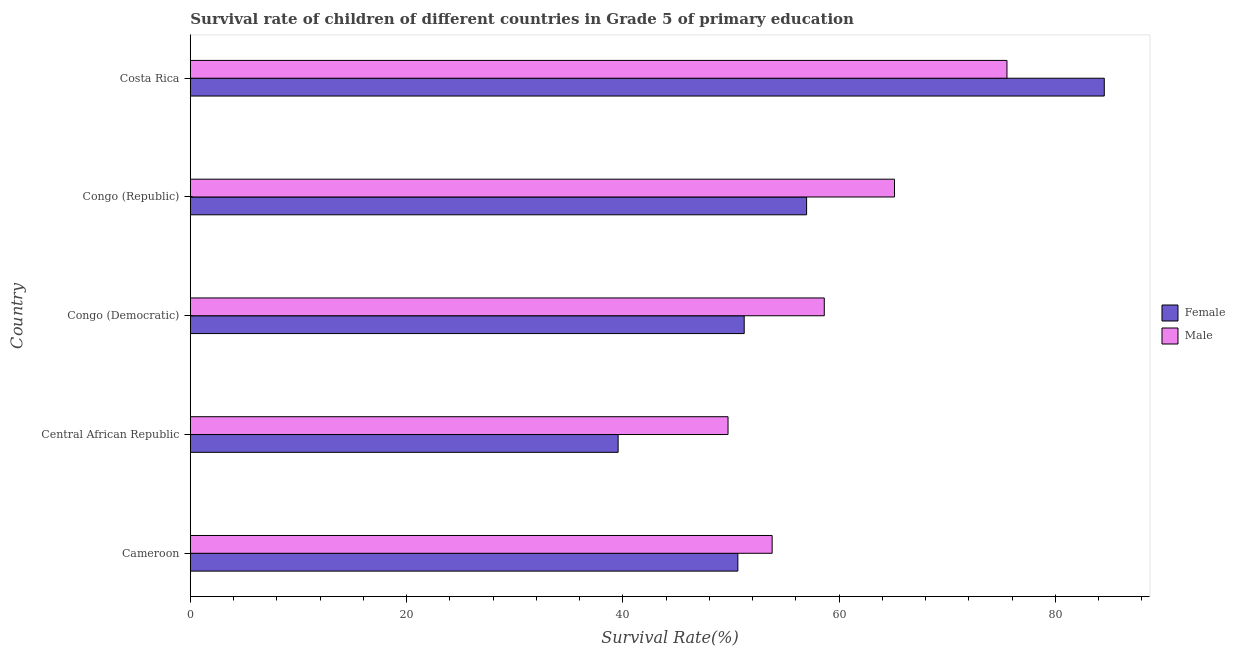How many groups of bars are there?
Ensure brevity in your answer.  5. How many bars are there on the 4th tick from the bottom?
Your answer should be very brief. 2. What is the label of the 5th group of bars from the top?
Your response must be concise. Cameroon. What is the survival rate of male students in primary education in Congo (Republic)?
Your answer should be very brief. 65.13. Across all countries, what is the maximum survival rate of male students in primary education?
Give a very brief answer. 75.53. Across all countries, what is the minimum survival rate of male students in primary education?
Provide a succinct answer. 49.73. In which country was the survival rate of male students in primary education maximum?
Offer a terse response. Costa Rica. In which country was the survival rate of female students in primary education minimum?
Ensure brevity in your answer.  Central African Republic. What is the total survival rate of female students in primary education in the graph?
Your answer should be compact. 282.97. What is the difference between the survival rate of female students in primary education in Cameroon and that in Costa Rica?
Your answer should be very brief. -33.89. What is the difference between the survival rate of male students in primary education in Costa Rica and the survival rate of female students in primary education in Cameroon?
Your response must be concise. 24.89. What is the average survival rate of female students in primary education per country?
Ensure brevity in your answer.  56.59. What is the difference between the survival rate of male students in primary education and survival rate of female students in primary education in Central African Republic?
Provide a short and direct response. 10.16. What is the ratio of the survival rate of female students in primary education in Cameroon to that in Congo (Republic)?
Offer a terse response. 0.89. Is the survival rate of female students in primary education in Congo (Democratic) less than that in Congo (Republic)?
Make the answer very short. Yes. Is the difference between the survival rate of male students in primary education in Cameroon and Costa Rica greater than the difference between the survival rate of female students in primary education in Cameroon and Costa Rica?
Offer a very short reply. Yes. What is the difference between the highest and the second highest survival rate of female students in primary education?
Your answer should be very brief. 27.53. What is the difference between the highest and the lowest survival rate of female students in primary education?
Provide a short and direct response. 44.96. In how many countries, is the survival rate of female students in primary education greater than the average survival rate of female students in primary education taken over all countries?
Offer a very short reply. 2. What does the 2nd bar from the bottom in Cameroon represents?
Your answer should be compact. Male. Are the values on the major ticks of X-axis written in scientific E-notation?
Your response must be concise. No. Does the graph contain any zero values?
Your answer should be compact. No. How many legend labels are there?
Ensure brevity in your answer.  2. How are the legend labels stacked?
Offer a very short reply. Vertical. What is the title of the graph?
Offer a very short reply. Survival rate of children of different countries in Grade 5 of primary education. Does "Nitrous oxide emissions" appear as one of the legend labels in the graph?
Your answer should be compact. No. What is the label or title of the X-axis?
Provide a succinct answer. Survival Rate(%). What is the label or title of the Y-axis?
Provide a succinct answer. Country. What is the Survival Rate(%) in Female in Cameroon?
Provide a short and direct response. 50.64. What is the Survival Rate(%) in Male in Cameroon?
Your answer should be compact. 53.81. What is the Survival Rate(%) in Female in Central African Republic?
Provide a succinct answer. 39.57. What is the Survival Rate(%) in Male in Central African Republic?
Your response must be concise. 49.73. What is the Survival Rate(%) in Female in Congo (Democratic)?
Your response must be concise. 51.23. What is the Survival Rate(%) of Male in Congo (Democratic)?
Your answer should be very brief. 58.64. What is the Survival Rate(%) in Female in Congo (Republic)?
Your response must be concise. 57. What is the Survival Rate(%) of Male in Congo (Republic)?
Your answer should be compact. 65.13. What is the Survival Rate(%) in Female in Costa Rica?
Provide a short and direct response. 84.53. What is the Survival Rate(%) of Male in Costa Rica?
Keep it short and to the point. 75.53. Across all countries, what is the maximum Survival Rate(%) of Female?
Provide a short and direct response. 84.53. Across all countries, what is the maximum Survival Rate(%) in Male?
Ensure brevity in your answer.  75.53. Across all countries, what is the minimum Survival Rate(%) of Female?
Your answer should be compact. 39.57. Across all countries, what is the minimum Survival Rate(%) of Male?
Ensure brevity in your answer.  49.73. What is the total Survival Rate(%) of Female in the graph?
Provide a short and direct response. 282.97. What is the total Survival Rate(%) of Male in the graph?
Give a very brief answer. 302.85. What is the difference between the Survival Rate(%) of Female in Cameroon and that in Central African Republic?
Keep it short and to the point. 11.07. What is the difference between the Survival Rate(%) in Male in Cameroon and that in Central African Republic?
Keep it short and to the point. 4.08. What is the difference between the Survival Rate(%) of Female in Cameroon and that in Congo (Democratic)?
Keep it short and to the point. -0.59. What is the difference between the Survival Rate(%) of Male in Cameroon and that in Congo (Democratic)?
Provide a short and direct response. -4.82. What is the difference between the Survival Rate(%) in Female in Cameroon and that in Congo (Republic)?
Your response must be concise. -6.36. What is the difference between the Survival Rate(%) of Male in Cameroon and that in Congo (Republic)?
Offer a very short reply. -11.32. What is the difference between the Survival Rate(%) of Female in Cameroon and that in Costa Rica?
Your response must be concise. -33.89. What is the difference between the Survival Rate(%) in Male in Cameroon and that in Costa Rica?
Your answer should be very brief. -21.72. What is the difference between the Survival Rate(%) of Female in Central African Republic and that in Congo (Democratic)?
Give a very brief answer. -11.66. What is the difference between the Survival Rate(%) in Male in Central African Republic and that in Congo (Democratic)?
Ensure brevity in your answer.  -8.9. What is the difference between the Survival Rate(%) of Female in Central African Republic and that in Congo (Republic)?
Give a very brief answer. -17.43. What is the difference between the Survival Rate(%) of Male in Central African Republic and that in Congo (Republic)?
Make the answer very short. -15.4. What is the difference between the Survival Rate(%) of Female in Central African Republic and that in Costa Rica?
Provide a short and direct response. -44.96. What is the difference between the Survival Rate(%) of Male in Central African Republic and that in Costa Rica?
Your answer should be compact. -25.8. What is the difference between the Survival Rate(%) of Female in Congo (Democratic) and that in Congo (Republic)?
Offer a very short reply. -5.77. What is the difference between the Survival Rate(%) in Male in Congo (Democratic) and that in Congo (Republic)?
Offer a terse response. -6.5. What is the difference between the Survival Rate(%) in Female in Congo (Democratic) and that in Costa Rica?
Ensure brevity in your answer.  -33.3. What is the difference between the Survival Rate(%) of Male in Congo (Democratic) and that in Costa Rica?
Keep it short and to the point. -16.9. What is the difference between the Survival Rate(%) of Female in Congo (Republic) and that in Costa Rica?
Your response must be concise. -27.53. What is the difference between the Survival Rate(%) in Male in Congo (Republic) and that in Costa Rica?
Your response must be concise. -10.4. What is the difference between the Survival Rate(%) in Female in Cameroon and the Survival Rate(%) in Male in Central African Republic?
Your response must be concise. 0.91. What is the difference between the Survival Rate(%) of Female in Cameroon and the Survival Rate(%) of Male in Congo (Democratic)?
Provide a succinct answer. -7.99. What is the difference between the Survival Rate(%) of Female in Cameroon and the Survival Rate(%) of Male in Congo (Republic)?
Ensure brevity in your answer.  -14.49. What is the difference between the Survival Rate(%) in Female in Cameroon and the Survival Rate(%) in Male in Costa Rica?
Provide a succinct answer. -24.89. What is the difference between the Survival Rate(%) in Female in Central African Republic and the Survival Rate(%) in Male in Congo (Democratic)?
Ensure brevity in your answer.  -19.07. What is the difference between the Survival Rate(%) of Female in Central African Republic and the Survival Rate(%) of Male in Congo (Republic)?
Your answer should be very brief. -25.56. What is the difference between the Survival Rate(%) in Female in Central African Republic and the Survival Rate(%) in Male in Costa Rica?
Your answer should be very brief. -35.96. What is the difference between the Survival Rate(%) of Female in Congo (Democratic) and the Survival Rate(%) of Male in Congo (Republic)?
Offer a very short reply. -13.9. What is the difference between the Survival Rate(%) of Female in Congo (Democratic) and the Survival Rate(%) of Male in Costa Rica?
Give a very brief answer. -24.3. What is the difference between the Survival Rate(%) in Female in Congo (Republic) and the Survival Rate(%) in Male in Costa Rica?
Provide a short and direct response. -18.53. What is the average Survival Rate(%) in Female per country?
Your response must be concise. 56.59. What is the average Survival Rate(%) in Male per country?
Provide a succinct answer. 60.57. What is the difference between the Survival Rate(%) of Female and Survival Rate(%) of Male in Cameroon?
Your response must be concise. -3.17. What is the difference between the Survival Rate(%) in Female and Survival Rate(%) in Male in Central African Republic?
Offer a terse response. -10.16. What is the difference between the Survival Rate(%) of Female and Survival Rate(%) of Male in Congo (Democratic)?
Provide a succinct answer. -7.41. What is the difference between the Survival Rate(%) of Female and Survival Rate(%) of Male in Congo (Republic)?
Offer a terse response. -8.13. What is the difference between the Survival Rate(%) in Female and Survival Rate(%) in Male in Costa Rica?
Your answer should be very brief. 9. What is the ratio of the Survival Rate(%) of Female in Cameroon to that in Central African Republic?
Your answer should be very brief. 1.28. What is the ratio of the Survival Rate(%) in Male in Cameroon to that in Central African Republic?
Your answer should be compact. 1.08. What is the ratio of the Survival Rate(%) in Female in Cameroon to that in Congo (Democratic)?
Provide a succinct answer. 0.99. What is the ratio of the Survival Rate(%) in Male in Cameroon to that in Congo (Democratic)?
Ensure brevity in your answer.  0.92. What is the ratio of the Survival Rate(%) of Female in Cameroon to that in Congo (Republic)?
Make the answer very short. 0.89. What is the ratio of the Survival Rate(%) in Male in Cameroon to that in Congo (Republic)?
Keep it short and to the point. 0.83. What is the ratio of the Survival Rate(%) of Female in Cameroon to that in Costa Rica?
Your answer should be very brief. 0.6. What is the ratio of the Survival Rate(%) of Male in Cameroon to that in Costa Rica?
Offer a terse response. 0.71. What is the ratio of the Survival Rate(%) of Female in Central African Republic to that in Congo (Democratic)?
Offer a terse response. 0.77. What is the ratio of the Survival Rate(%) of Male in Central African Republic to that in Congo (Democratic)?
Your answer should be very brief. 0.85. What is the ratio of the Survival Rate(%) of Female in Central African Republic to that in Congo (Republic)?
Offer a very short reply. 0.69. What is the ratio of the Survival Rate(%) of Male in Central African Republic to that in Congo (Republic)?
Offer a very short reply. 0.76. What is the ratio of the Survival Rate(%) in Female in Central African Republic to that in Costa Rica?
Provide a short and direct response. 0.47. What is the ratio of the Survival Rate(%) of Male in Central African Republic to that in Costa Rica?
Provide a succinct answer. 0.66. What is the ratio of the Survival Rate(%) of Female in Congo (Democratic) to that in Congo (Republic)?
Your answer should be compact. 0.9. What is the ratio of the Survival Rate(%) of Male in Congo (Democratic) to that in Congo (Republic)?
Ensure brevity in your answer.  0.9. What is the ratio of the Survival Rate(%) of Female in Congo (Democratic) to that in Costa Rica?
Offer a very short reply. 0.61. What is the ratio of the Survival Rate(%) in Male in Congo (Democratic) to that in Costa Rica?
Make the answer very short. 0.78. What is the ratio of the Survival Rate(%) of Female in Congo (Republic) to that in Costa Rica?
Provide a succinct answer. 0.67. What is the ratio of the Survival Rate(%) of Male in Congo (Republic) to that in Costa Rica?
Your response must be concise. 0.86. What is the difference between the highest and the second highest Survival Rate(%) of Female?
Provide a succinct answer. 27.53. What is the difference between the highest and the second highest Survival Rate(%) of Male?
Your response must be concise. 10.4. What is the difference between the highest and the lowest Survival Rate(%) of Female?
Give a very brief answer. 44.96. What is the difference between the highest and the lowest Survival Rate(%) in Male?
Your answer should be very brief. 25.8. 